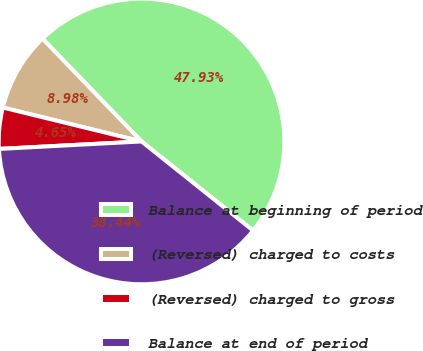<chart> <loc_0><loc_0><loc_500><loc_500><pie_chart><fcel>Balance at beginning of period<fcel>(Reversed) charged to costs<fcel>(Reversed) charged to gross<fcel>Balance at end of period<nl><fcel>47.93%<fcel>8.98%<fcel>4.65%<fcel>38.44%<nl></chart> 